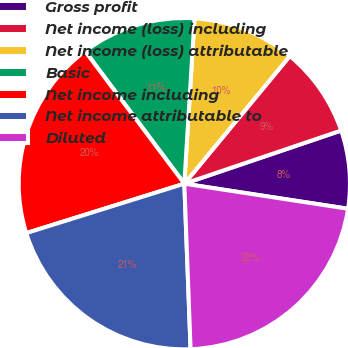<chart> <loc_0><loc_0><loc_500><loc_500><pie_chart><fcel>Gross profit<fcel>Net income (loss) including<fcel>Net income (loss) attributable<fcel>Basic<fcel>Net income including<fcel>Net income attributable to<fcel>Diluted<nl><fcel>7.62%<fcel>8.81%<fcel>10.01%<fcel>11.21%<fcel>19.59%<fcel>20.78%<fcel>21.98%<nl></chart> 